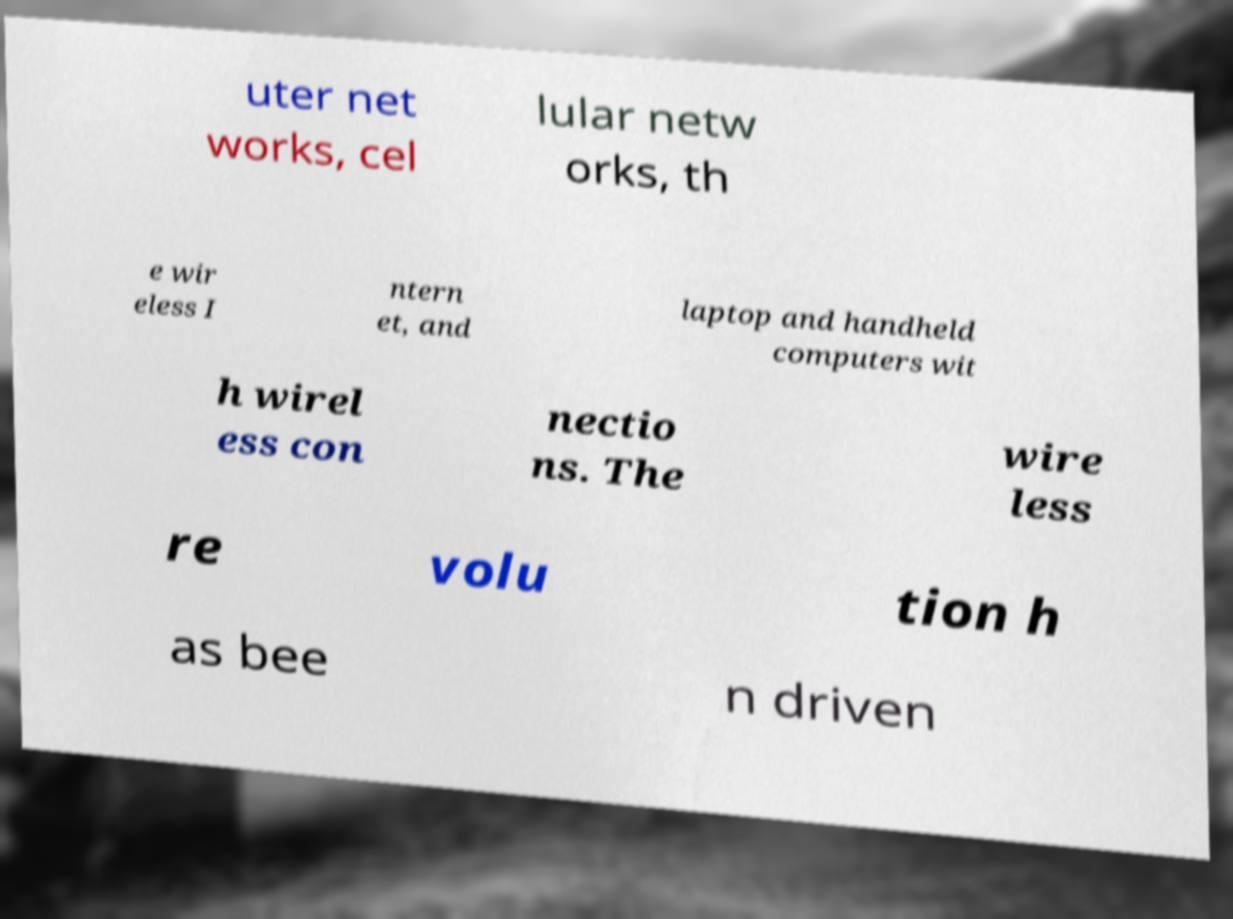Could you assist in decoding the text presented in this image and type it out clearly? uter net works, cel lular netw orks, th e wir eless I ntern et, and laptop and handheld computers wit h wirel ess con nectio ns. The wire less re volu tion h as bee n driven 